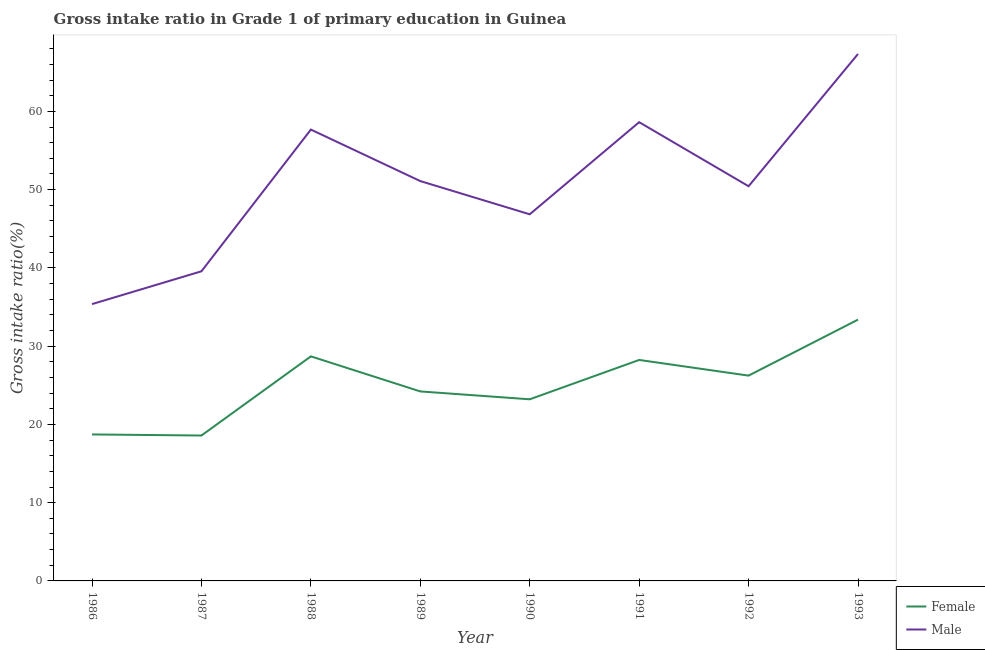Does the line corresponding to gross intake ratio(female) intersect with the line corresponding to gross intake ratio(male)?
Offer a terse response. No. What is the gross intake ratio(female) in 1993?
Give a very brief answer. 33.39. Across all years, what is the maximum gross intake ratio(female)?
Offer a terse response. 33.39. Across all years, what is the minimum gross intake ratio(female)?
Provide a succinct answer. 18.58. In which year was the gross intake ratio(female) maximum?
Provide a short and direct response. 1993. What is the total gross intake ratio(female) in the graph?
Provide a succinct answer. 201.27. What is the difference between the gross intake ratio(female) in 1988 and that in 1993?
Offer a terse response. -4.7. What is the difference between the gross intake ratio(male) in 1991 and the gross intake ratio(female) in 1990?
Give a very brief answer. 35.41. What is the average gross intake ratio(male) per year?
Give a very brief answer. 50.87. In the year 1988, what is the difference between the gross intake ratio(male) and gross intake ratio(female)?
Keep it short and to the point. 28.98. In how many years, is the gross intake ratio(female) greater than 54 %?
Offer a terse response. 0. What is the ratio of the gross intake ratio(male) in 1989 to that in 1992?
Your answer should be compact. 1.01. Is the gross intake ratio(male) in 1986 less than that in 1988?
Give a very brief answer. Yes. What is the difference between the highest and the second highest gross intake ratio(female)?
Provide a succinct answer. 4.7. What is the difference between the highest and the lowest gross intake ratio(female)?
Keep it short and to the point. 14.81. Is the sum of the gross intake ratio(female) in 1989 and 1990 greater than the maximum gross intake ratio(male) across all years?
Keep it short and to the point. No. How many lines are there?
Keep it short and to the point. 2. How many years are there in the graph?
Make the answer very short. 8. What is the difference between two consecutive major ticks on the Y-axis?
Offer a very short reply. 10. Does the graph contain any zero values?
Provide a short and direct response. No. Where does the legend appear in the graph?
Provide a short and direct response. Bottom right. What is the title of the graph?
Offer a terse response. Gross intake ratio in Grade 1 of primary education in Guinea. What is the label or title of the Y-axis?
Offer a very short reply. Gross intake ratio(%). What is the Gross intake ratio(%) of Female in 1986?
Your response must be concise. 18.72. What is the Gross intake ratio(%) of Male in 1986?
Ensure brevity in your answer.  35.37. What is the Gross intake ratio(%) in Female in 1987?
Provide a short and direct response. 18.58. What is the Gross intake ratio(%) of Male in 1987?
Offer a very short reply. 39.56. What is the Gross intake ratio(%) in Female in 1988?
Provide a short and direct response. 28.69. What is the Gross intake ratio(%) of Male in 1988?
Provide a succinct answer. 57.67. What is the Gross intake ratio(%) in Female in 1989?
Give a very brief answer. 24.21. What is the Gross intake ratio(%) in Male in 1989?
Your answer should be compact. 51.09. What is the Gross intake ratio(%) in Female in 1990?
Give a very brief answer. 23.21. What is the Gross intake ratio(%) of Male in 1990?
Your response must be concise. 46.85. What is the Gross intake ratio(%) of Female in 1991?
Ensure brevity in your answer.  28.24. What is the Gross intake ratio(%) in Male in 1991?
Make the answer very short. 58.62. What is the Gross intake ratio(%) of Female in 1992?
Your answer should be compact. 26.23. What is the Gross intake ratio(%) in Male in 1992?
Offer a terse response. 50.43. What is the Gross intake ratio(%) in Female in 1993?
Your answer should be compact. 33.39. What is the Gross intake ratio(%) in Male in 1993?
Give a very brief answer. 67.34. Across all years, what is the maximum Gross intake ratio(%) of Female?
Keep it short and to the point. 33.39. Across all years, what is the maximum Gross intake ratio(%) of Male?
Provide a short and direct response. 67.34. Across all years, what is the minimum Gross intake ratio(%) of Female?
Your answer should be very brief. 18.58. Across all years, what is the minimum Gross intake ratio(%) of Male?
Offer a terse response. 35.37. What is the total Gross intake ratio(%) in Female in the graph?
Offer a very short reply. 201.27. What is the total Gross intake ratio(%) of Male in the graph?
Your answer should be compact. 406.93. What is the difference between the Gross intake ratio(%) in Female in 1986 and that in 1987?
Your answer should be very brief. 0.14. What is the difference between the Gross intake ratio(%) in Male in 1986 and that in 1987?
Keep it short and to the point. -4.19. What is the difference between the Gross intake ratio(%) in Female in 1986 and that in 1988?
Keep it short and to the point. -9.98. What is the difference between the Gross intake ratio(%) in Male in 1986 and that in 1988?
Provide a succinct answer. -22.3. What is the difference between the Gross intake ratio(%) of Female in 1986 and that in 1989?
Provide a succinct answer. -5.5. What is the difference between the Gross intake ratio(%) of Male in 1986 and that in 1989?
Your answer should be very brief. -15.72. What is the difference between the Gross intake ratio(%) of Female in 1986 and that in 1990?
Keep it short and to the point. -4.49. What is the difference between the Gross intake ratio(%) of Male in 1986 and that in 1990?
Keep it short and to the point. -11.47. What is the difference between the Gross intake ratio(%) in Female in 1986 and that in 1991?
Your answer should be compact. -9.52. What is the difference between the Gross intake ratio(%) of Male in 1986 and that in 1991?
Offer a very short reply. -23.25. What is the difference between the Gross intake ratio(%) of Female in 1986 and that in 1992?
Give a very brief answer. -7.52. What is the difference between the Gross intake ratio(%) in Male in 1986 and that in 1992?
Your answer should be compact. -15.06. What is the difference between the Gross intake ratio(%) of Female in 1986 and that in 1993?
Your response must be concise. -14.67. What is the difference between the Gross intake ratio(%) of Male in 1986 and that in 1993?
Offer a very short reply. -31.96. What is the difference between the Gross intake ratio(%) of Female in 1987 and that in 1988?
Your answer should be very brief. -10.11. What is the difference between the Gross intake ratio(%) in Male in 1987 and that in 1988?
Provide a succinct answer. -18.11. What is the difference between the Gross intake ratio(%) of Female in 1987 and that in 1989?
Keep it short and to the point. -5.63. What is the difference between the Gross intake ratio(%) in Male in 1987 and that in 1989?
Offer a terse response. -11.53. What is the difference between the Gross intake ratio(%) in Female in 1987 and that in 1990?
Your answer should be very brief. -4.63. What is the difference between the Gross intake ratio(%) of Male in 1987 and that in 1990?
Your answer should be very brief. -7.28. What is the difference between the Gross intake ratio(%) of Female in 1987 and that in 1991?
Your response must be concise. -9.66. What is the difference between the Gross intake ratio(%) of Male in 1987 and that in 1991?
Keep it short and to the point. -19.05. What is the difference between the Gross intake ratio(%) of Female in 1987 and that in 1992?
Ensure brevity in your answer.  -7.65. What is the difference between the Gross intake ratio(%) in Male in 1987 and that in 1992?
Ensure brevity in your answer.  -10.87. What is the difference between the Gross intake ratio(%) in Female in 1987 and that in 1993?
Your response must be concise. -14.81. What is the difference between the Gross intake ratio(%) in Male in 1987 and that in 1993?
Provide a short and direct response. -27.77. What is the difference between the Gross intake ratio(%) of Female in 1988 and that in 1989?
Keep it short and to the point. 4.48. What is the difference between the Gross intake ratio(%) in Male in 1988 and that in 1989?
Keep it short and to the point. 6.58. What is the difference between the Gross intake ratio(%) in Female in 1988 and that in 1990?
Make the answer very short. 5.49. What is the difference between the Gross intake ratio(%) in Male in 1988 and that in 1990?
Provide a short and direct response. 10.83. What is the difference between the Gross intake ratio(%) in Female in 1988 and that in 1991?
Give a very brief answer. 0.46. What is the difference between the Gross intake ratio(%) of Male in 1988 and that in 1991?
Keep it short and to the point. -0.95. What is the difference between the Gross intake ratio(%) in Female in 1988 and that in 1992?
Provide a succinct answer. 2.46. What is the difference between the Gross intake ratio(%) of Male in 1988 and that in 1992?
Offer a terse response. 7.24. What is the difference between the Gross intake ratio(%) of Female in 1988 and that in 1993?
Offer a terse response. -4.7. What is the difference between the Gross intake ratio(%) of Male in 1988 and that in 1993?
Your response must be concise. -9.66. What is the difference between the Gross intake ratio(%) in Female in 1989 and that in 1990?
Your answer should be compact. 1.01. What is the difference between the Gross intake ratio(%) in Male in 1989 and that in 1990?
Make the answer very short. 4.24. What is the difference between the Gross intake ratio(%) of Female in 1989 and that in 1991?
Your answer should be very brief. -4.02. What is the difference between the Gross intake ratio(%) in Male in 1989 and that in 1991?
Your response must be concise. -7.53. What is the difference between the Gross intake ratio(%) in Female in 1989 and that in 1992?
Your response must be concise. -2.02. What is the difference between the Gross intake ratio(%) of Male in 1989 and that in 1992?
Ensure brevity in your answer.  0.66. What is the difference between the Gross intake ratio(%) in Female in 1989 and that in 1993?
Keep it short and to the point. -9.18. What is the difference between the Gross intake ratio(%) of Male in 1989 and that in 1993?
Offer a terse response. -16.24. What is the difference between the Gross intake ratio(%) in Female in 1990 and that in 1991?
Make the answer very short. -5.03. What is the difference between the Gross intake ratio(%) of Male in 1990 and that in 1991?
Provide a succinct answer. -11.77. What is the difference between the Gross intake ratio(%) in Female in 1990 and that in 1992?
Offer a very short reply. -3.03. What is the difference between the Gross intake ratio(%) of Male in 1990 and that in 1992?
Provide a short and direct response. -3.59. What is the difference between the Gross intake ratio(%) of Female in 1990 and that in 1993?
Keep it short and to the point. -10.18. What is the difference between the Gross intake ratio(%) in Male in 1990 and that in 1993?
Offer a very short reply. -20.49. What is the difference between the Gross intake ratio(%) in Female in 1991 and that in 1992?
Provide a short and direct response. 2. What is the difference between the Gross intake ratio(%) in Male in 1991 and that in 1992?
Keep it short and to the point. 8.19. What is the difference between the Gross intake ratio(%) in Female in 1991 and that in 1993?
Your answer should be very brief. -5.15. What is the difference between the Gross intake ratio(%) of Male in 1991 and that in 1993?
Ensure brevity in your answer.  -8.72. What is the difference between the Gross intake ratio(%) of Female in 1992 and that in 1993?
Provide a short and direct response. -7.15. What is the difference between the Gross intake ratio(%) in Male in 1992 and that in 1993?
Your answer should be compact. -16.9. What is the difference between the Gross intake ratio(%) of Female in 1986 and the Gross intake ratio(%) of Male in 1987?
Your answer should be compact. -20.85. What is the difference between the Gross intake ratio(%) in Female in 1986 and the Gross intake ratio(%) in Male in 1988?
Keep it short and to the point. -38.96. What is the difference between the Gross intake ratio(%) of Female in 1986 and the Gross intake ratio(%) of Male in 1989?
Provide a short and direct response. -32.37. What is the difference between the Gross intake ratio(%) in Female in 1986 and the Gross intake ratio(%) in Male in 1990?
Offer a very short reply. -28.13. What is the difference between the Gross intake ratio(%) of Female in 1986 and the Gross intake ratio(%) of Male in 1991?
Your answer should be very brief. -39.9. What is the difference between the Gross intake ratio(%) in Female in 1986 and the Gross intake ratio(%) in Male in 1992?
Ensure brevity in your answer.  -31.72. What is the difference between the Gross intake ratio(%) in Female in 1986 and the Gross intake ratio(%) in Male in 1993?
Ensure brevity in your answer.  -48.62. What is the difference between the Gross intake ratio(%) in Female in 1987 and the Gross intake ratio(%) in Male in 1988?
Your answer should be compact. -39.09. What is the difference between the Gross intake ratio(%) of Female in 1987 and the Gross intake ratio(%) of Male in 1989?
Ensure brevity in your answer.  -32.51. What is the difference between the Gross intake ratio(%) in Female in 1987 and the Gross intake ratio(%) in Male in 1990?
Provide a succinct answer. -28.27. What is the difference between the Gross intake ratio(%) of Female in 1987 and the Gross intake ratio(%) of Male in 1991?
Make the answer very short. -40.04. What is the difference between the Gross intake ratio(%) of Female in 1987 and the Gross intake ratio(%) of Male in 1992?
Your answer should be compact. -31.85. What is the difference between the Gross intake ratio(%) in Female in 1987 and the Gross intake ratio(%) in Male in 1993?
Your answer should be very brief. -48.76. What is the difference between the Gross intake ratio(%) of Female in 1988 and the Gross intake ratio(%) of Male in 1989?
Give a very brief answer. -22.4. What is the difference between the Gross intake ratio(%) of Female in 1988 and the Gross intake ratio(%) of Male in 1990?
Provide a succinct answer. -18.15. What is the difference between the Gross intake ratio(%) in Female in 1988 and the Gross intake ratio(%) in Male in 1991?
Your response must be concise. -29.92. What is the difference between the Gross intake ratio(%) of Female in 1988 and the Gross intake ratio(%) of Male in 1992?
Give a very brief answer. -21.74. What is the difference between the Gross intake ratio(%) in Female in 1988 and the Gross intake ratio(%) in Male in 1993?
Your answer should be compact. -38.64. What is the difference between the Gross intake ratio(%) of Female in 1989 and the Gross intake ratio(%) of Male in 1990?
Keep it short and to the point. -22.63. What is the difference between the Gross intake ratio(%) of Female in 1989 and the Gross intake ratio(%) of Male in 1991?
Your answer should be very brief. -34.41. What is the difference between the Gross intake ratio(%) in Female in 1989 and the Gross intake ratio(%) in Male in 1992?
Offer a very short reply. -26.22. What is the difference between the Gross intake ratio(%) in Female in 1989 and the Gross intake ratio(%) in Male in 1993?
Make the answer very short. -43.12. What is the difference between the Gross intake ratio(%) in Female in 1990 and the Gross intake ratio(%) in Male in 1991?
Ensure brevity in your answer.  -35.41. What is the difference between the Gross intake ratio(%) in Female in 1990 and the Gross intake ratio(%) in Male in 1992?
Provide a succinct answer. -27.23. What is the difference between the Gross intake ratio(%) in Female in 1990 and the Gross intake ratio(%) in Male in 1993?
Your response must be concise. -44.13. What is the difference between the Gross intake ratio(%) of Female in 1991 and the Gross intake ratio(%) of Male in 1992?
Your answer should be very brief. -22.2. What is the difference between the Gross intake ratio(%) in Female in 1991 and the Gross intake ratio(%) in Male in 1993?
Make the answer very short. -39.1. What is the difference between the Gross intake ratio(%) of Female in 1992 and the Gross intake ratio(%) of Male in 1993?
Your response must be concise. -41.1. What is the average Gross intake ratio(%) in Female per year?
Offer a terse response. 25.16. What is the average Gross intake ratio(%) of Male per year?
Your response must be concise. 50.87. In the year 1986, what is the difference between the Gross intake ratio(%) in Female and Gross intake ratio(%) in Male?
Offer a terse response. -16.65. In the year 1987, what is the difference between the Gross intake ratio(%) of Female and Gross intake ratio(%) of Male?
Provide a succinct answer. -20.98. In the year 1988, what is the difference between the Gross intake ratio(%) of Female and Gross intake ratio(%) of Male?
Offer a terse response. -28.98. In the year 1989, what is the difference between the Gross intake ratio(%) in Female and Gross intake ratio(%) in Male?
Offer a terse response. -26.88. In the year 1990, what is the difference between the Gross intake ratio(%) of Female and Gross intake ratio(%) of Male?
Your response must be concise. -23.64. In the year 1991, what is the difference between the Gross intake ratio(%) of Female and Gross intake ratio(%) of Male?
Provide a succinct answer. -30.38. In the year 1992, what is the difference between the Gross intake ratio(%) of Female and Gross intake ratio(%) of Male?
Provide a short and direct response. -24.2. In the year 1993, what is the difference between the Gross intake ratio(%) in Female and Gross intake ratio(%) in Male?
Make the answer very short. -33.95. What is the ratio of the Gross intake ratio(%) in Female in 1986 to that in 1987?
Your answer should be compact. 1.01. What is the ratio of the Gross intake ratio(%) of Male in 1986 to that in 1987?
Your answer should be compact. 0.89. What is the ratio of the Gross intake ratio(%) of Female in 1986 to that in 1988?
Ensure brevity in your answer.  0.65. What is the ratio of the Gross intake ratio(%) of Male in 1986 to that in 1988?
Your answer should be compact. 0.61. What is the ratio of the Gross intake ratio(%) of Female in 1986 to that in 1989?
Your response must be concise. 0.77. What is the ratio of the Gross intake ratio(%) in Male in 1986 to that in 1989?
Provide a short and direct response. 0.69. What is the ratio of the Gross intake ratio(%) in Female in 1986 to that in 1990?
Your answer should be compact. 0.81. What is the ratio of the Gross intake ratio(%) of Male in 1986 to that in 1990?
Your response must be concise. 0.76. What is the ratio of the Gross intake ratio(%) of Female in 1986 to that in 1991?
Provide a succinct answer. 0.66. What is the ratio of the Gross intake ratio(%) in Male in 1986 to that in 1991?
Provide a succinct answer. 0.6. What is the ratio of the Gross intake ratio(%) in Female in 1986 to that in 1992?
Offer a terse response. 0.71. What is the ratio of the Gross intake ratio(%) of Male in 1986 to that in 1992?
Give a very brief answer. 0.7. What is the ratio of the Gross intake ratio(%) in Female in 1986 to that in 1993?
Your answer should be very brief. 0.56. What is the ratio of the Gross intake ratio(%) in Male in 1986 to that in 1993?
Offer a terse response. 0.53. What is the ratio of the Gross intake ratio(%) in Female in 1987 to that in 1988?
Give a very brief answer. 0.65. What is the ratio of the Gross intake ratio(%) of Male in 1987 to that in 1988?
Offer a terse response. 0.69. What is the ratio of the Gross intake ratio(%) in Female in 1987 to that in 1989?
Provide a succinct answer. 0.77. What is the ratio of the Gross intake ratio(%) in Male in 1987 to that in 1989?
Keep it short and to the point. 0.77. What is the ratio of the Gross intake ratio(%) in Female in 1987 to that in 1990?
Offer a very short reply. 0.8. What is the ratio of the Gross intake ratio(%) in Male in 1987 to that in 1990?
Keep it short and to the point. 0.84. What is the ratio of the Gross intake ratio(%) in Female in 1987 to that in 1991?
Ensure brevity in your answer.  0.66. What is the ratio of the Gross intake ratio(%) in Male in 1987 to that in 1991?
Ensure brevity in your answer.  0.67. What is the ratio of the Gross intake ratio(%) in Female in 1987 to that in 1992?
Your response must be concise. 0.71. What is the ratio of the Gross intake ratio(%) of Male in 1987 to that in 1992?
Your answer should be compact. 0.78. What is the ratio of the Gross intake ratio(%) in Female in 1987 to that in 1993?
Provide a succinct answer. 0.56. What is the ratio of the Gross intake ratio(%) of Male in 1987 to that in 1993?
Keep it short and to the point. 0.59. What is the ratio of the Gross intake ratio(%) of Female in 1988 to that in 1989?
Ensure brevity in your answer.  1.19. What is the ratio of the Gross intake ratio(%) in Male in 1988 to that in 1989?
Give a very brief answer. 1.13. What is the ratio of the Gross intake ratio(%) in Female in 1988 to that in 1990?
Your response must be concise. 1.24. What is the ratio of the Gross intake ratio(%) in Male in 1988 to that in 1990?
Keep it short and to the point. 1.23. What is the ratio of the Gross intake ratio(%) in Female in 1988 to that in 1991?
Keep it short and to the point. 1.02. What is the ratio of the Gross intake ratio(%) in Male in 1988 to that in 1991?
Offer a terse response. 0.98. What is the ratio of the Gross intake ratio(%) of Female in 1988 to that in 1992?
Offer a terse response. 1.09. What is the ratio of the Gross intake ratio(%) of Male in 1988 to that in 1992?
Offer a very short reply. 1.14. What is the ratio of the Gross intake ratio(%) of Female in 1988 to that in 1993?
Provide a short and direct response. 0.86. What is the ratio of the Gross intake ratio(%) of Male in 1988 to that in 1993?
Keep it short and to the point. 0.86. What is the ratio of the Gross intake ratio(%) in Female in 1989 to that in 1990?
Provide a short and direct response. 1.04. What is the ratio of the Gross intake ratio(%) of Male in 1989 to that in 1990?
Provide a short and direct response. 1.09. What is the ratio of the Gross intake ratio(%) of Female in 1989 to that in 1991?
Provide a short and direct response. 0.86. What is the ratio of the Gross intake ratio(%) of Male in 1989 to that in 1991?
Ensure brevity in your answer.  0.87. What is the ratio of the Gross intake ratio(%) of Female in 1989 to that in 1992?
Your answer should be very brief. 0.92. What is the ratio of the Gross intake ratio(%) of Male in 1989 to that in 1992?
Your answer should be very brief. 1.01. What is the ratio of the Gross intake ratio(%) in Female in 1989 to that in 1993?
Provide a short and direct response. 0.73. What is the ratio of the Gross intake ratio(%) of Male in 1989 to that in 1993?
Provide a succinct answer. 0.76. What is the ratio of the Gross intake ratio(%) of Female in 1990 to that in 1991?
Ensure brevity in your answer.  0.82. What is the ratio of the Gross intake ratio(%) of Male in 1990 to that in 1991?
Offer a terse response. 0.8. What is the ratio of the Gross intake ratio(%) in Female in 1990 to that in 1992?
Provide a short and direct response. 0.88. What is the ratio of the Gross intake ratio(%) of Male in 1990 to that in 1992?
Keep it short and to the point. 0.93. What is the ratio of the Gross intake ratio(%) in Female in 1990 to that in 1993?
Your answer should be compact. 0.7. What is the ratio of the Gross intake ratio(%) in Male in 1990 to that in 1993?
Ensure brevity in your answer.  0.7. What is the ratio of the Gross intake ratio(%) of Female in 1991 to that in 1992?
Your response must be concise. 1.08. What is the ratio of the Gross intake ratio(%) of Male in 1991 to that in 1992?
Your response must be concise. 1.16. What is the ratio of the Gross intake ratio(%) in Female in 1991 to that in 1993?
Ensure brevity in your answer.  0.85. What is the ratio of the Gross intake ratio(%) of Male in 1991 to that in 1993?
Your answer should be compact. 0.87. What is the ratio of the Gross intake ratio(%) in Female in 1992 to that in 1993?
Give a very brief answer. 0.79. What is the ratio of the Gross intake ratio(%) of Male in 1992 to that in 1993?
Ensure brevity in your answer.  0.75. What is the difference between the highest and the second highest Gross intake ratio(%) in Female?
Keep it short and to the point. 4.7. What is the difference between the highest and the second highest Gross intake ratio(%) in Male?
Keep it short and to the point. 8.72. What is the difference between the highest and the lowest Gross intake ratio(%) of Female?
Offer a very short reply. 14.81. What is the difference between the highest and the lowest Gross intake ratio(%) of Male?
Ensure brevity in your answer.  31.96. 